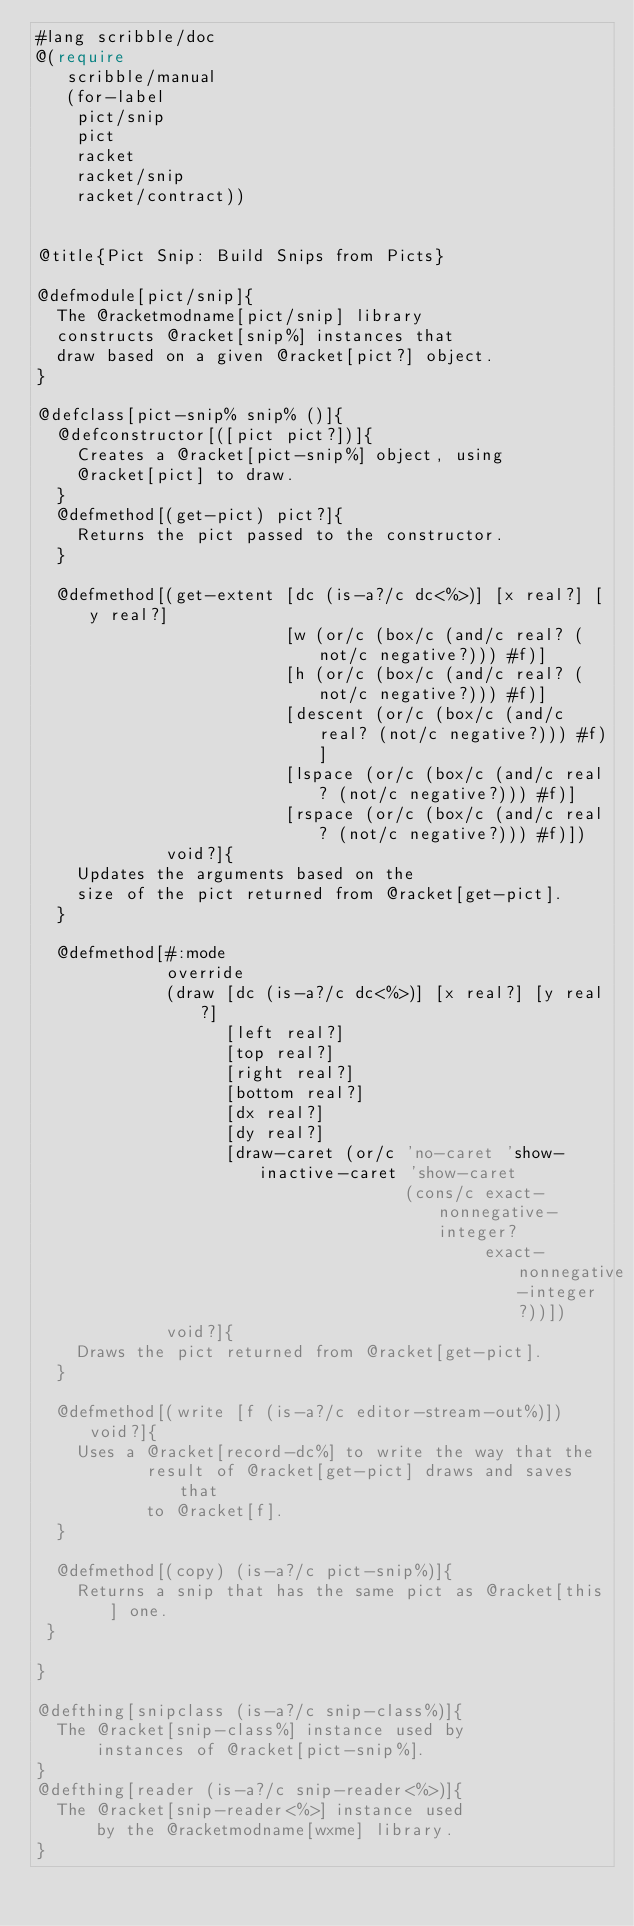<code> <loc_0><loc_0><loc_500><loc_500><_Racket_>#lang scribble/doc
@(require 
   scribble/manual
   (for-label
    pict/snip
    pict
    racket
    racket/snip
    racket/contract))


@title{Pict Snip: Build Snips from Picts}

@defmodule[pict/snip]{ 
  The @racketmodname[pict/snip] library
  constructs @racket[snip%] instances that
  draw based on a given @racket[pict?] object.
}

@defclass[pict-snip% snip% ()]{
  @defconstructor[([pict pict?])]{
    Creates a @racket[pict-snip%] object, using
    @racket[pict] to draw.
  }
  @defmethod[(get-pict) pict?]{
    Returns the pict passed to the constructor.
  }
  
  @defmethod[(get-extent [dc (is-a?/c dc<%>)] [x real?] [y real?]
                         [w (or/c (box/c (and/c real? (not/c negative?))) #f)]
                         [h (or/c (box/c (and/c real? (not/c negative?))) #f)]
                         [descent (or/c (box/c (and/c real? (not/c negative?))) #f)]
                         [lspace (or/c (box/c (and/c real? (not/c negative?))) #f)]
                         [rspace (or/c (box/c (and/c real? (not/c negative?))) #f)])
             void?]{
    Updates the arguments based on the 
    size of the pict returned from @racket[get-pict].
  }

  @defmethod[#:mode 
             override
             (draw [dc (is-a?/c dc<%>)] [x real?] [y real?]
                   [left real?]
                   [top real?]
                   [right real?]
                   [bottom real?]
                   [dx real?]
                   [dy real?]
                   [draw-caret (or/c 'no-caret 'show-inactive-caret 'show-caret
                                     (cons/c exact-nonnegative-integer?
                                             exact-nonnegative-integer?))])
             void?]{
    Draws the pict returned from @racket[get-pict].
  }
  
  @defmethod[(write [f (is-a?/c editor-stream-out%)]) void?]{
    Uses a @racket[record-dc%] to write the way that the
           result of @racket[get-pict] draws and saves that
           to @racket[f].
  }
                                                                            
  @defmethod[(copy) (is-a?/c pict-snip%)]{
    Returns a snip that has the same pict as @racket[this] one.
 }
  
}

@defthing[snipclass (is-a?/c snip-class%)]{
  The @racket[snip-class%] instance used by
      instances of @racket[pict-snip%].
}
@defthing[reader (is-a?/c snip-reader<%>)]{
  The @racket[snip-reader<%>] instance used
      by the @racketmodname[wxme] library.
}
</code> 